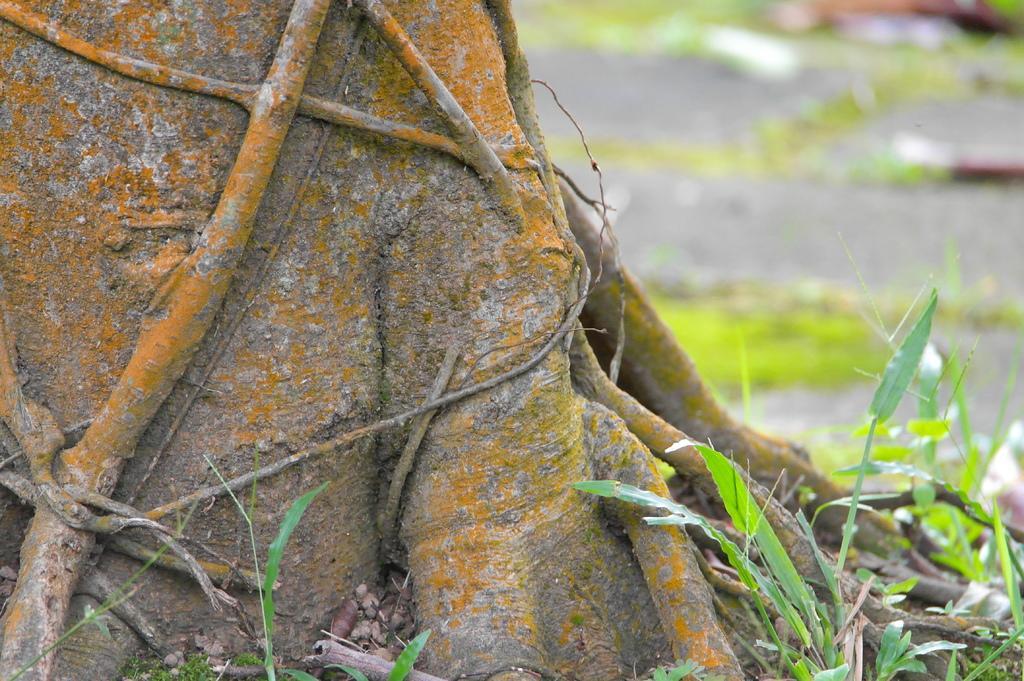How would you summarize this image in a sentence or two? In this image in the front there is plant and on the left side there are roots of a tree and the background is blurry. 